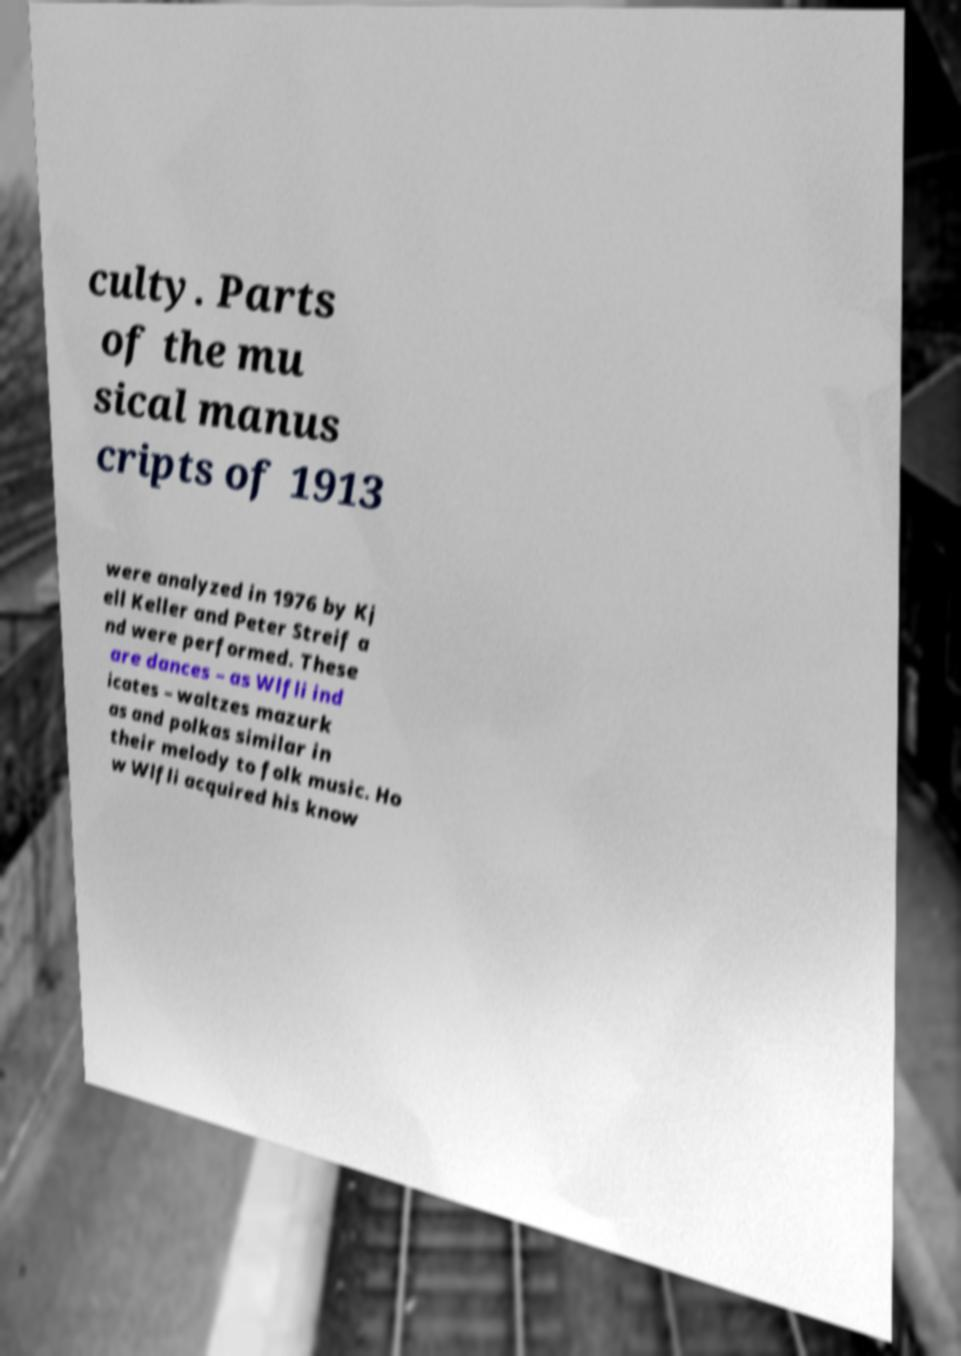Can you read and provide the text displayed in the image?This photo seems to have some interesting text. Can you extract and type it out for me? culty. Parts of the mu sical manus cripts of 1913 were analyzed in 1976 by Kj ell Keller and Peter Streif a nd were performed. These are dances – as Wlfli ind icates – waltzes mazurk as and polkas similar in their melody to folk music. Ho w Wlfli acquired his know 